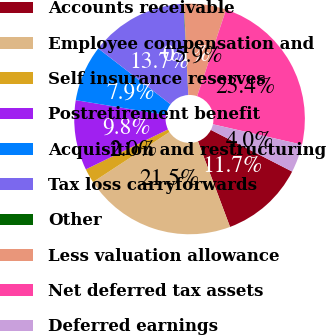Convert chart to OTSL. <chart><loc_0><loc_0><loc_500><loc_500><pie_chart><fcel>Accounts receivable<fcel>Employee compensation and<fcel>Self insurance reserves<fcel>Postretirement benefit<fcel>Acquisition and restructuring<fcel>Tax loss carryforwards<fcel>Other<fcel>Less valuation allowance<fcel>Net deferred tax assets<fcel>Deferred earnings<nl><fcel>11.75%<fcel>21.5%<fcel>2.01%<fcel>9.81%<fcel>7.86%<fcel>13.7%<fcel>0.06%<fcel>5.91%<fcel>23.45%<fcel>3.96%<nl></chart> 